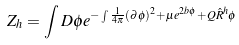Convert formula to latex. <formula><loc_0><loc_0><loc_500><loc_500>Z _ { h } = \int D \phi e ^ { - \int \frac { 1 } { 4 \pi } ( \partial \phi ) ^ { 2 } + \mu e ^ { 2 b \phi } + Q \hat { R } ^ { h } \phi }</formula> 